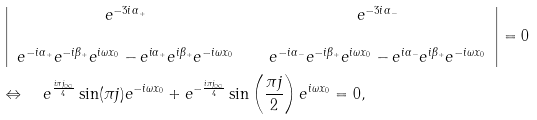<formula> <loc_0><loc_0><loc_500><loc_500>& \left | \begin{array} { c c c } e ^ { - 3 i \alpha _ { + } } & \, & e ^ { - 3 i \alpha _ { - } } \\ & & \\ e ^ { - i \alpha _ { + } } e ^ { - i \beta _ { + } } e ^ { i \omega x _ { 0 } } - e ^ { i \alpha _ { + } } e ^ { i \beta _ { + } } e ^ { - i \omega x _ { 0 } } & & e ^ { - i \alpha _ { - } } e ^ { - i \beta _ { + } } e ^ { i \omega x _ { 0 } } - e ^ { i \alpha _ { - } } e ^ { i \beta _ { + } } e ^ { - i \omega x _ { 0 } } \end{array} \right | = 0 \\ & \Leftrightarrow \quad e ^ { \frac { i \pi { j _ { \infty } } } 4 } \sin ( \pi j ) e ^ { - i \omega x _ { 0 } } + e ^ { - \frac { i \pi { j _ { \infty } } } 4 } \sin \left ( \frac { \pi j } 2 \right ) e ^ { i \omega x _ { 0 } } = 0 ,</formula> 